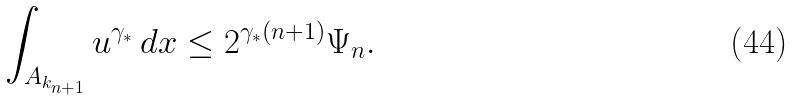Convert formula to latex. <formula><loc_0><loc_0><loc_500><loc_500>\int _ { A _ { k _ { n + 1 } } } u ^ { \gamma _ { * } } \, d x \leq 2 ^ { \gamma _ { * } ( n + 1 ) } \Psi _ { n } .</formula> 